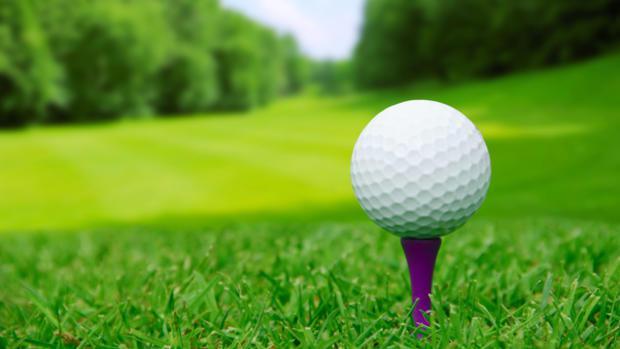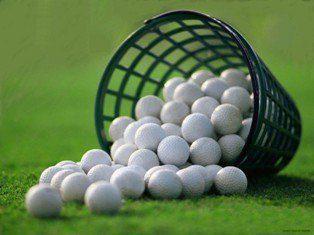The first image is the image on the left, the second image is the image on the right. Considering the images on both sides, is "An image shows one golf ball next to a hole that does not have a pole in it." valid? Answer yes or no. No. The first image is the image on the left, the second image is the image on the right. Analyze the images presented: Is the assertion "There is a ball near the hole in at least one of the images." valid? Answer yes or no. No. 